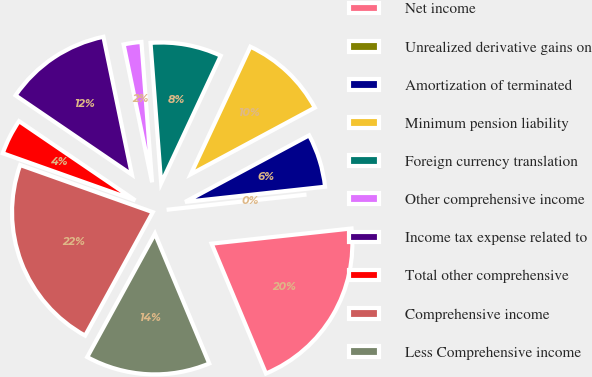<chart> <loc_0><loc_0><loc_500><loc_500><pie_chart><fcel>Net income<fcel>Unrealized derivative gains on<fcel>Amortization of terminated<fcel>Minimum pension liability<fcel>Foreign currency translation<fcel>Other comprehensive income<fcel>Income tax expense related to<fcel>Total other comprehensive<fcel>Comprehensive income<fcel>Less Comprehensive income<nl><fcel>20.41%<fcel>0.0%<fcel>6.12%<fcel>10.2%<fcel>8.16%<fcel>2.04%<fcel>12.24%<fcel>4.08%<fcel>22.45%<fcel>14.29%<nl></chart> 